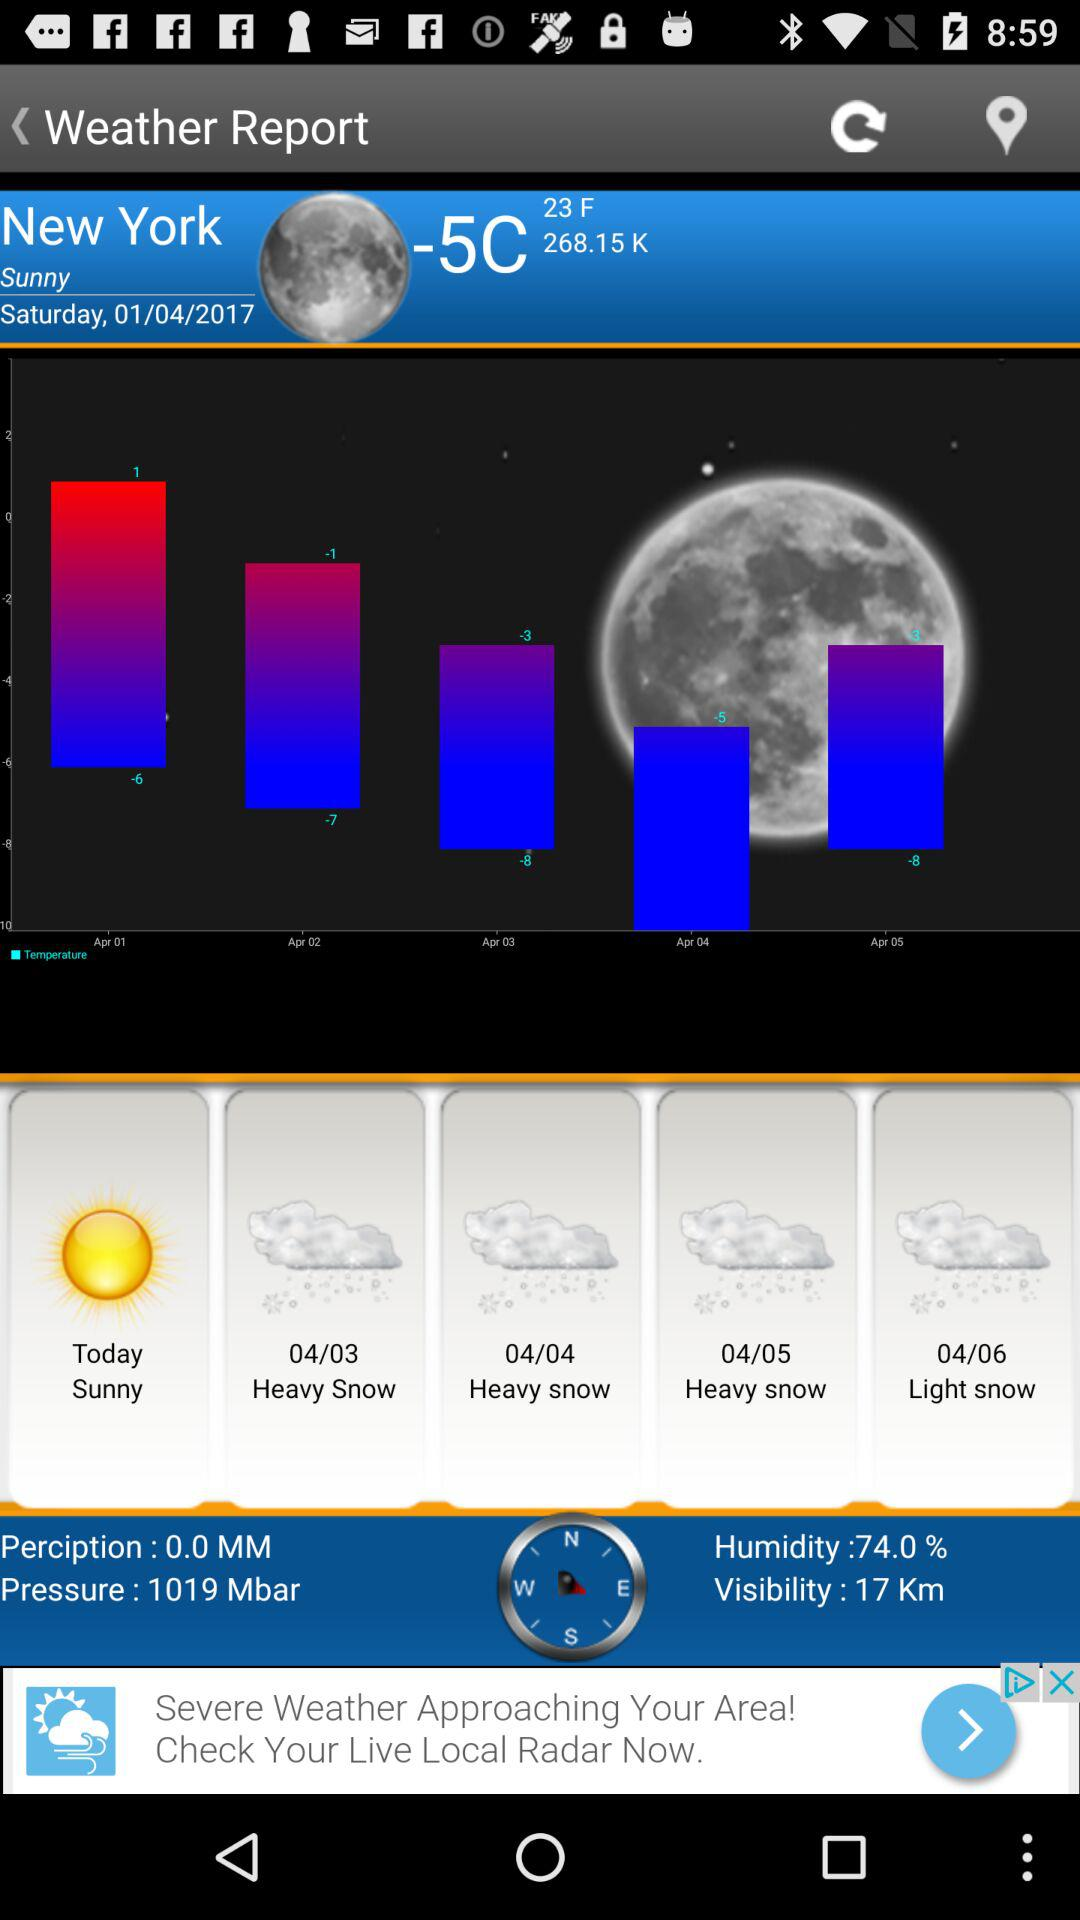What is the visibility today? The visibility is 17 km. 